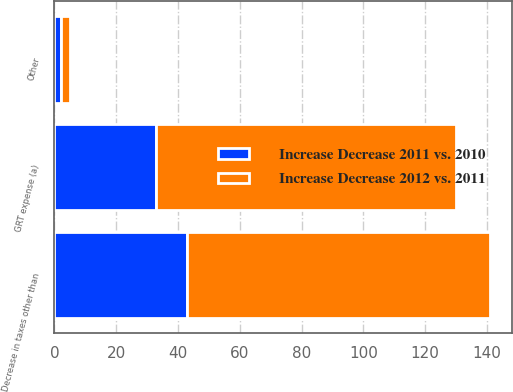Convert chart to OTSL. <chart><loc_0><loc_0><loc_500><loc_500><stacked_bar_chart><ecel><fcel>GRT expense (a)<fcel>Other<fcel>Decrease in taxes other than<nl><fcel>Increase Decrease 2011 vs. 2010<fcel>33<fcel>2<fcel>43<nl><fcel>Increase Decrease 2012 vs. 2011<fcel>97<fcel>3<fcel>98<nl></chart> 